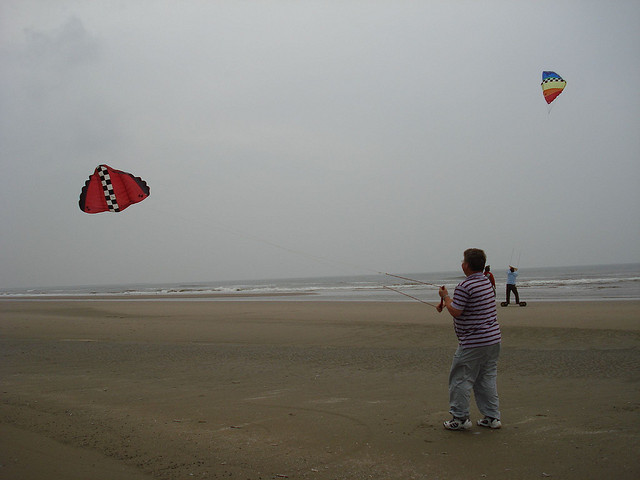<image>What kind of suit is the man wearing? The man is not wearing a suit. However, it could be casual clothes or a tracksuit. What kind of suit is the man wearing? The man is not wearing a suit. He is wearing casual clothes. 